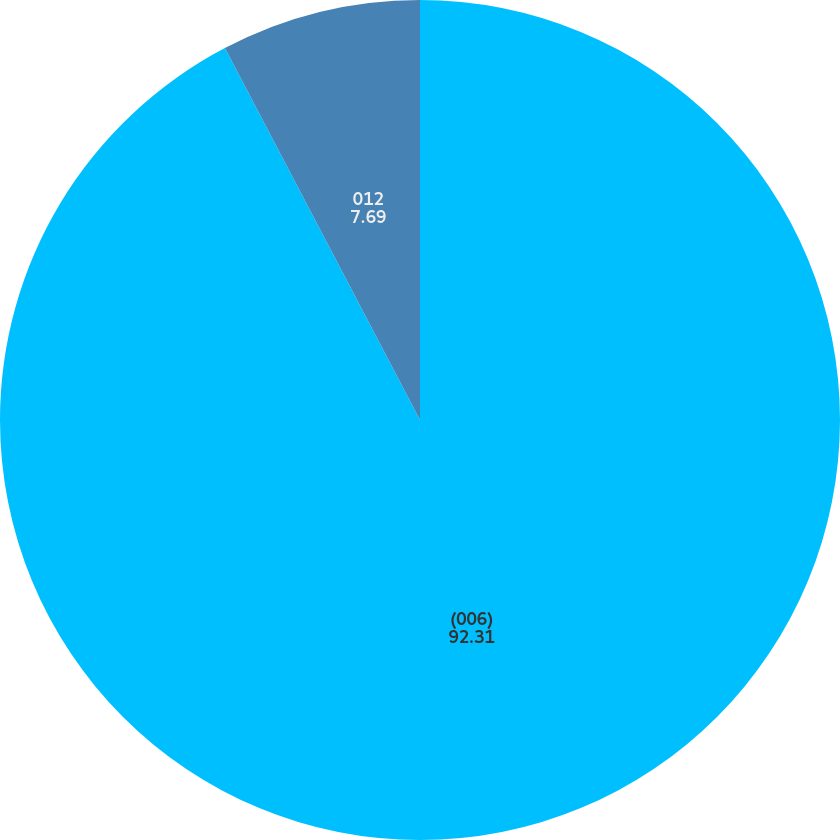Convert chart. <chart><loc_0><loc_0><loc_500><loc_500><pie_chart><fcel>(006)<fcel>012<nl><fcel>92.31%<fcel>7.69%<nl></chart> 